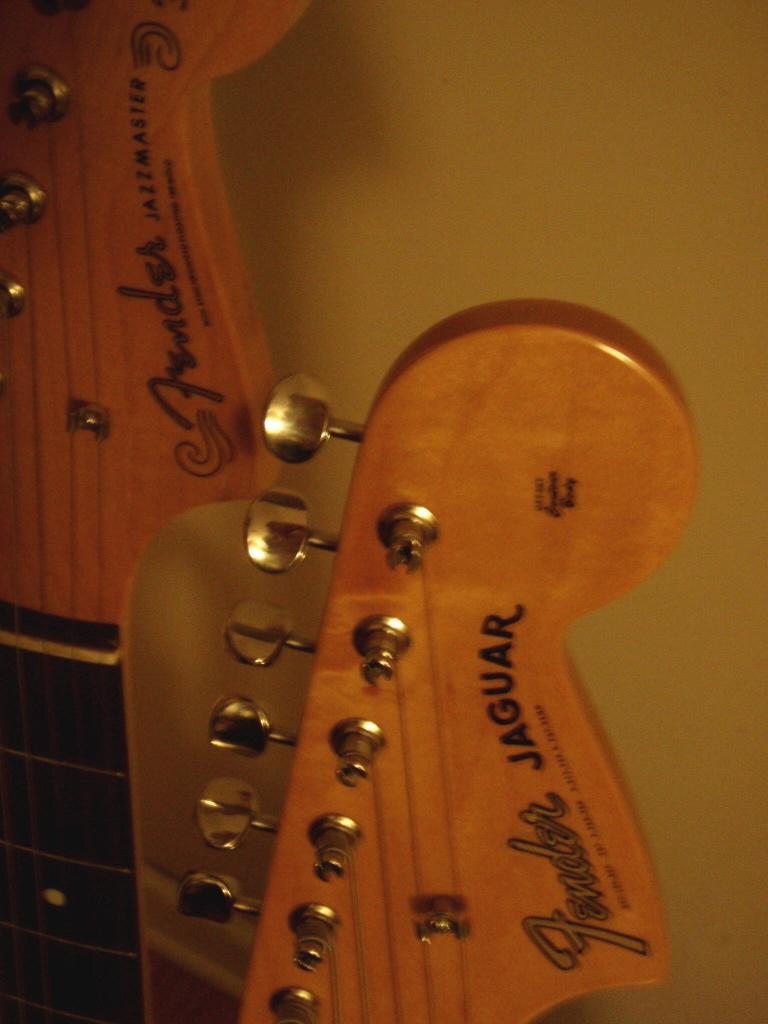In one or two sentences, can you explain what this image depicts? In this picture there is a musical instrument. 